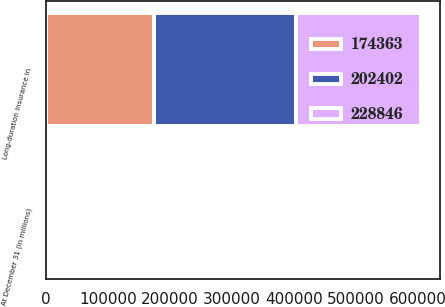<chart> <loc_0><loc_0><loc_500><loc_500><stacked_bar_chart><ecel><fcel>At December 31 (in millions)<fcel>Long-duration insurance in<nl><fcel>202402<fcel>2018<fcel>228846<nl><fcel>228846<fcel>2017<fcel>202402<nl><fcel>174363<fcel>2016<fcel>174363<nl></chart> 